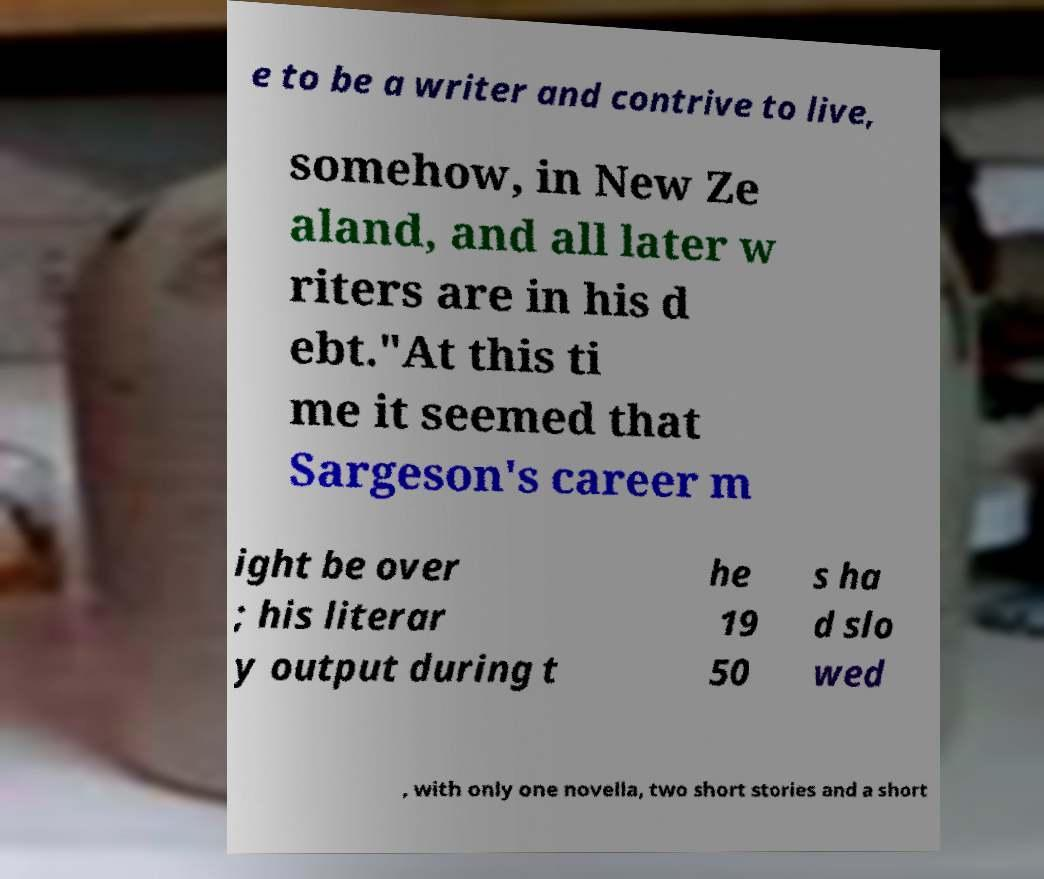There's text embedded in this image that I need extracted. Can you transcribe it verbatim? e to be a writer and contrive to live, somehow, in New Ze aland, and all later w riters are in his d ebt."At this ti me it seemed that Sargeson's career m ight be over ; his literar y output during t he 19 50 s ha d slo wed , with only one novella, two short stories and a short 